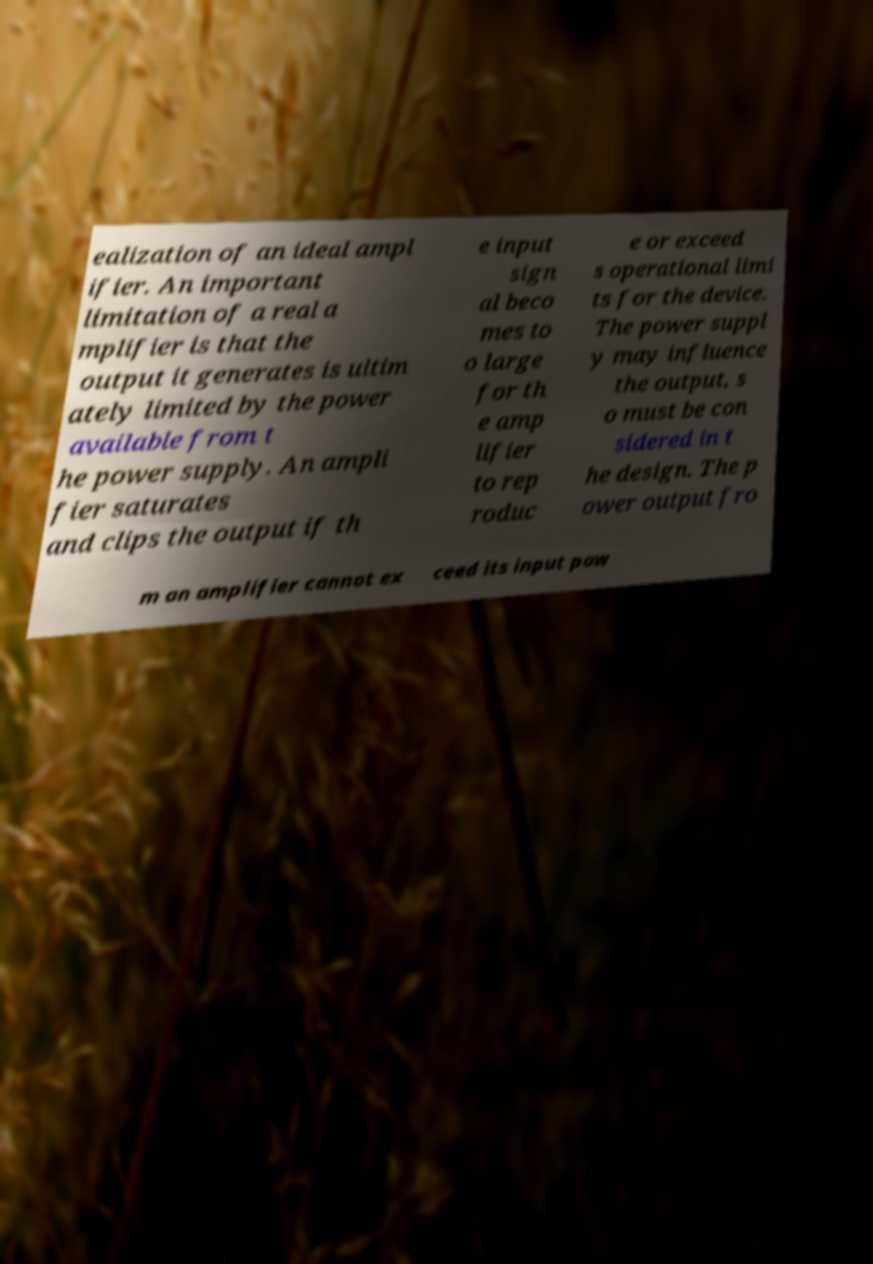Can you accurately transcribe the text from the provided image for me? ealization of an ideal ampl ifier. An important limitation of a real a mplifier is that the output it generates is ultim ately limited by the power available from t he power supply. An ampli fier saturates and clips the output if th e input sign al beco mes to o large for th e amp lifier to rep roduc e or exceed s operational limi ts for the device. The power suppl y may influence the output, s o must be con sidered in t he design. The p ower output fro m an amplifier cannot ex ceed its input pow 